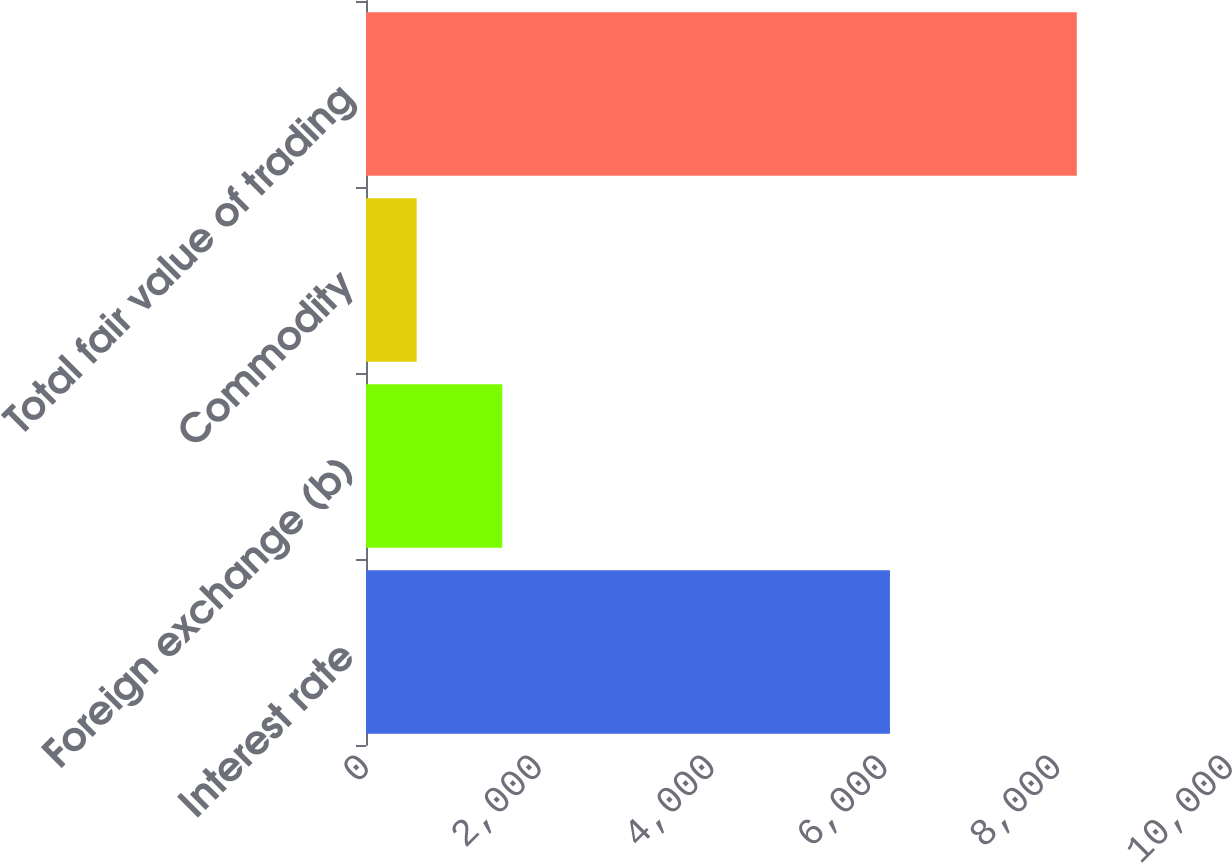Convert chart. <chart><loc_0><loc_0><loc_500><loc_500><bar_chart><fcel>Interest rate<fcel>Foreign exchange (b)<fcel>Commodity<fcel>Total fair value of trading<nl><fcel>6064<fcel>1577<fcel>586<fcel>8227<nl></chart> 